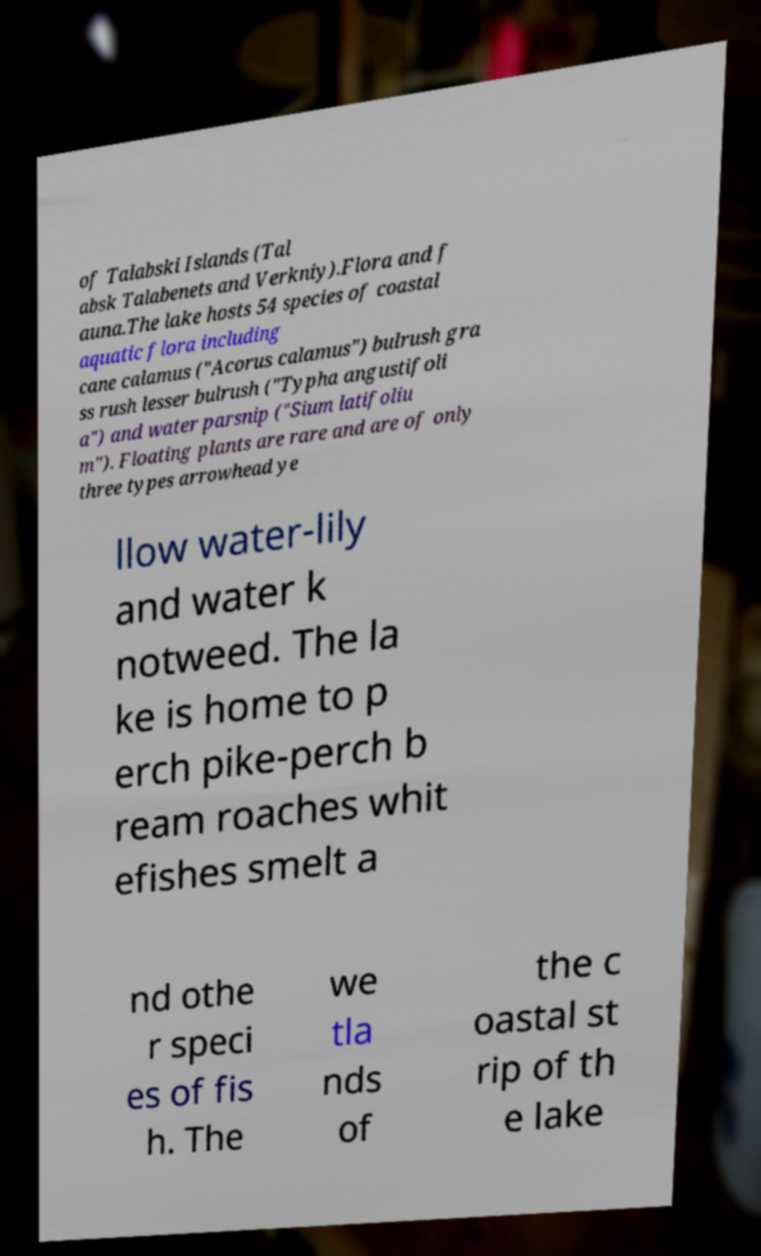For documentation purposes, I need the text within this image transcribed. Could you provide that? of Talabski Islands (Tal absk Talabenets and Verkniy).Flora and f auna.The lake hosts 54 species of coastal aquatic flora including cane calamus ("Acorus calamus") bulrush gra ss rush lesser bulrush ("Typha angustifoli a") and water parsnip ("Sium latifoliu m"). Floating plants are rare and are of only three types arrowhead ye llow water-lily and water k notweed. The la ke is home to p erch pike-perch b ream roaches whit efishes smelt a nd othe r speci es of fis h. The we tla nds of the c oastal st rip of th e lake 